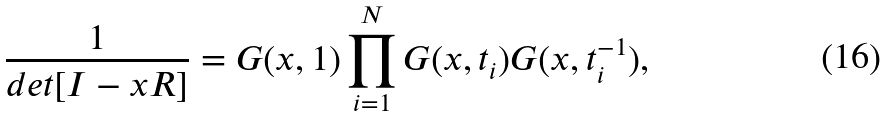Convert formula to latex. <formula><loc_0><loc_0><loc_500><loc_500>\frac { 1 } { d e t [ I - x R ] } = G ( x , 1 ) \prod _ { i = 1 } ^ { N } G ( x , t _ { i } ) G ( x , t _ { i } ^ { - 1 } ) ,</formula> 